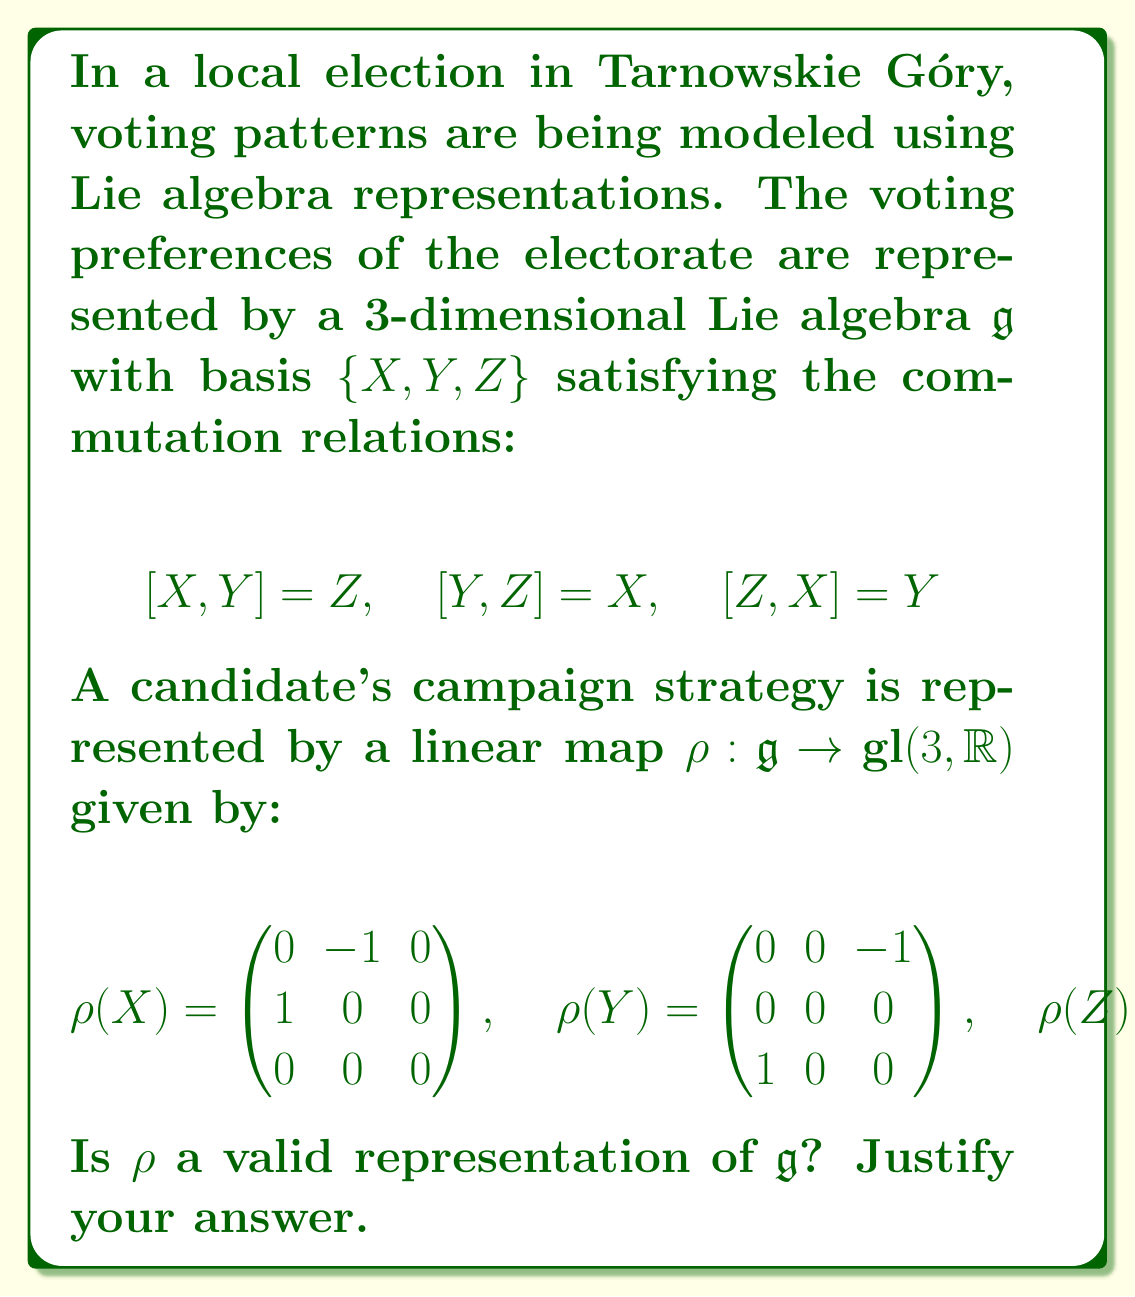Show me your answer to this math problem. To determine if $\rho$ is a valid representation of the Lie algebra $\mathfrak{g}$, we need to check if it preserves the Lie bracket. In other words, we need to verify that for all $A, B \in \mathfrak{g}$:

$$\rho([A,B]) = [\rho(A), \rho(B)]$$

where the bracket on the right-hand side is the commutator of matrices.

Let's check this for each pair of basis elements:

1. For $[X,Y] = Z$:
   $$[\rho(X), \rho(Y)] = \begin{pmatrix} 0 & -1 & 0 \\ 1 & 0 & 0 \\ 0 & 0 & 0 \end{pmatrix}\begin{pmatrix} 0 & 0 & -1 \\ 0 & 0 & 0 \\ 1 & 0 & 0 \end{pmatrix} - \begin{pmatrix} 0 & 0 & -1 \\ 0 & 0 & 0 \\ 1 & 0 & 0 \end{pmatrix}\begin{pmatrix} 0 & -1 & 0 \\ 1 & 0 & 0 \\ 0 & 0 & 0 \end{pmatrix}$$
   $$= \begin{pmatrix} 0 & 0 & 0 \\ 0 & 0 & -1 \\ 0 & 1 & 0 \end{pmatrix} = \rho(Z)$$

2. For $[Y,Z] = X$:
   $$[\rho(Y), \rho(Z)] = \begin{pmatrix} 0 & 0 & -1 \\ 0 & 0 & 0 \\ 1 & 0 & 0 \end{pmatrix}\begin{pmatrix} 0 & 0 & 0 \\ 0 & 0 & -1 \\ 0 & 1 & 0 \end{pmatrix} - \begin{pmatrix} 0 & 0 & 0 \\ 0 & 0 & -1 \\ 0 & 1 & 0 \end{pmatrix}\begin{pmatrix} 0 & 0 & -1 \\ 0 & 0 & 0 \\ 1 & 0 & 0 \end{pmatrix}$$
   $$= \begin{pmatrix} 0 & -1 & 0 \\ 1 & 0 & 0 \\ 0 & 0 & 0 \end{pmatrix} = \rho(X)$$

3. For $[Z,X] = Y$:
   $$[\rho(Z), \rho(X)] = \begin{pmatrix} 0 & 0 & 0 \\ 0 & 0 & -1 \\ 0 & 1 & 0 \end{pmatrix}\begin{pmatrix} 0 & -1 & 0 \\ 1 & 0 & 0 \\ 0 & 0 & 0 \end{pmatrix} - \begin{pmatrix} 0 & -1 & 0 \\ 1 & 0 & 0 \\ 0 & 0 & 0 \end{pmatrix}\begin{pmatrix} 0 & 0 & 0 \\ 0 & 0 & -1 \\ 0 & 1 & 0 \end{pmatrix}$$
   $$= \begin{pmatrix} 0 & 0 & -1 \\ 0 & 0 & 0 \\ 1 & 0 & 0 \end{pmatrix} = \rho(Y)$$

Since the Lie bracket is preserved for all basis elements, and $\rho$ is linear, it preserves the Lie bracket for all elements of $\mathfrak{g}$.
Answer: Yes, $\rho$ is a valid representation of $\mathfrak{g}$. 